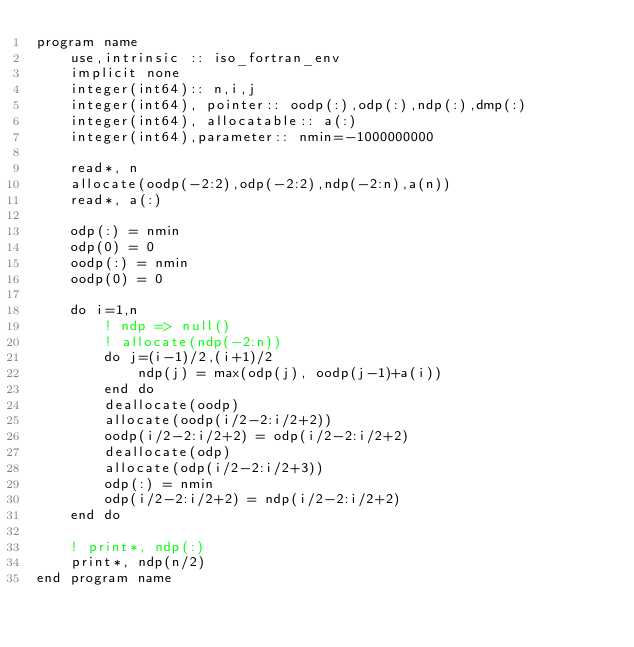Convert code to text. <code><loc_0><loc_0><loc_500><loc_500><_FORTRAN_>program name
    use,intrinsic :: iso_fortran_env
    implicit none
    integer(int64):: n,i,j
    integer(int64), pointer:: oodp(:),odp(:),ndp(:),dmp(:)
    integer(int64), allocatable:: a(:)
    integer(int64),parameter:: nmin=-1000000000

    read*, n
    allocate(oodp(-2:2),odp(-2:2),ndp(-2:n),a(n))
    read*, a(:)

    odp(:) = nmin
    odp(0) = 0
    oodp(:) = nmin
    oodp(0) = 0

    do i=1,n
        ! ndp => null()
        ! allocate(ndp(-2:n))
        do j=(i-1)/2,(i+1)/2
            ndp(j) = max(odp(j), oodp(j-1)+a(i))
        end do
        deallocate(oodp)
        allocate(oodp(i/2-2:i/2+2))
        oodp(i/2-2:i/2+2) = odp(i/2-2:i/2+2)
        deallocate(odp)
        allocate(odp(i/2-2:i/2+3))
        odp(:) = nmin
        odp(i/2-2:i/2+2) = ndp(i/2-2:i/2+2)
    end do

    ! print*, ndp(:)
    print*, ndp(n/2)
end program name</code> 